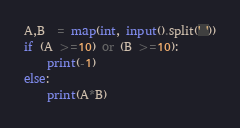Convert code to text. <code><loc_0><loc_0><loc_500><loc_500><_Python_>A,B  = map(int, input().split(' '))
if (A >=10) or (B >=10):
    print(-1)
else:
    print(A*B)</code> 